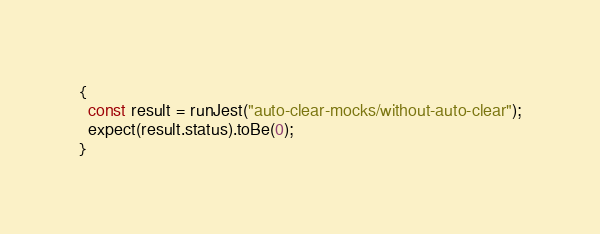<code> <loc_0><loc_0><loc_500><loc_500><_JavaScript_>{
  const result = runJest("auto-clear-mocks/without-auto-clear");
  expect(result.status).toBe(0);
}
</code> 